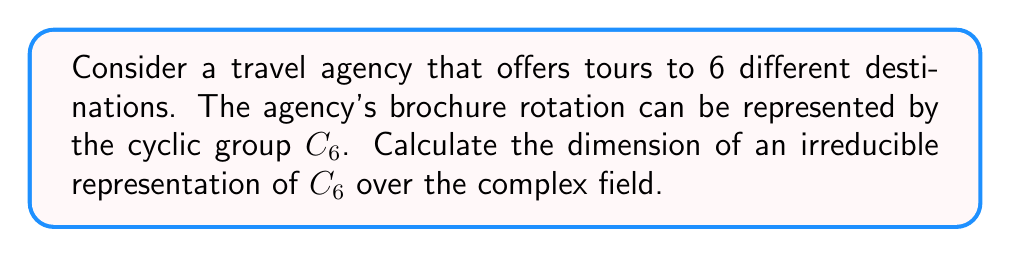Provide a solution to this math problem. To solve this problem, we'll follow these steps:

1) First, recall that for a cyclic group $C_n$, there are exactly $n$ irreducible representations over the complex field, each of dimension 1.

2) In this case, we have $C_6$, so there are 6 irreducible representations.

3) The irreducible representations of $C_6$ are given by the characters:

   $\chi_k(g^j) = e^{2\pi i k j / 6}$, where $k = 0, 1, 2, 3, 4, 5$ and $g$ is a generator of $C_6$.

4) Each of these characters defines a 1-dimensional representation.

5) The dimension of an irreducible representation is equal to the degree of the corresponding character.

6) In this case, all characters are of degree 1, so all irreducible representations have dimension 1.

Therefore, the dimension of any irreducible representation of $C_6$ is 1.
Answer: 1 